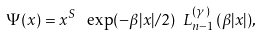Convert formula to latex. <formula><loc_0><loc_0><loc_500><loc_500>\Psi ( x ) = x ^ { S } \ \exp ( - \beta | x | / 2 ) \ L _ { n - 1 } ^ { ( \gamma ) } ( \beta | x | ) ,</formula> 